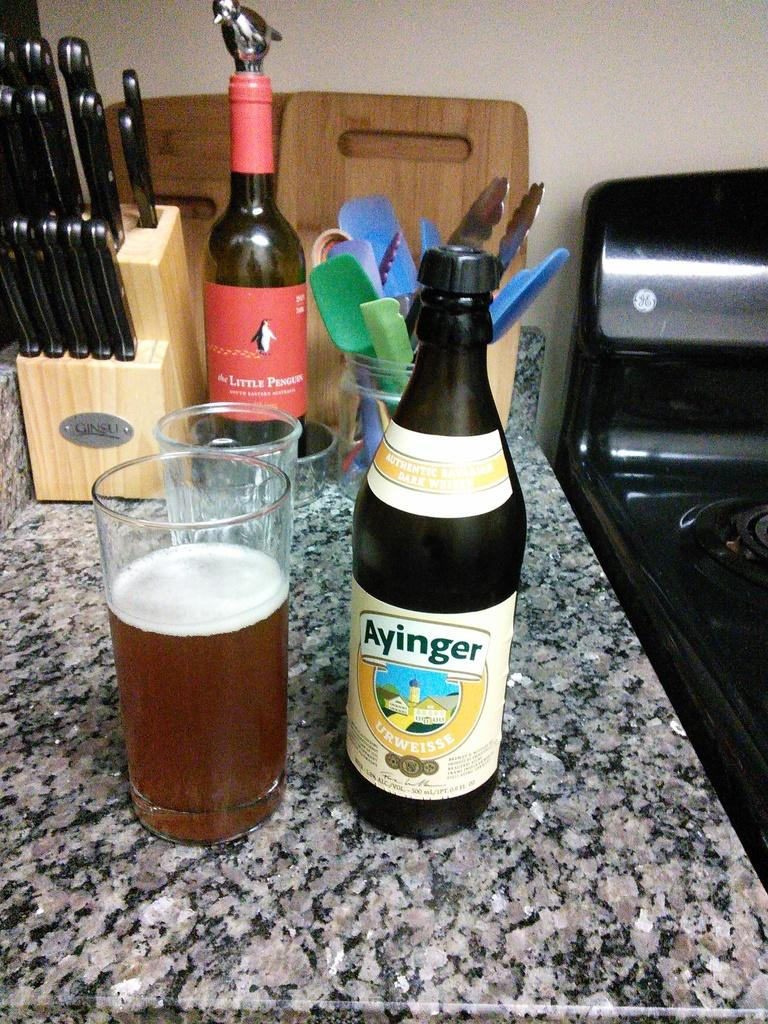<image>
Render a clear and concise summary of the photo. Bottle of Ayinger next to a cup of beer. 